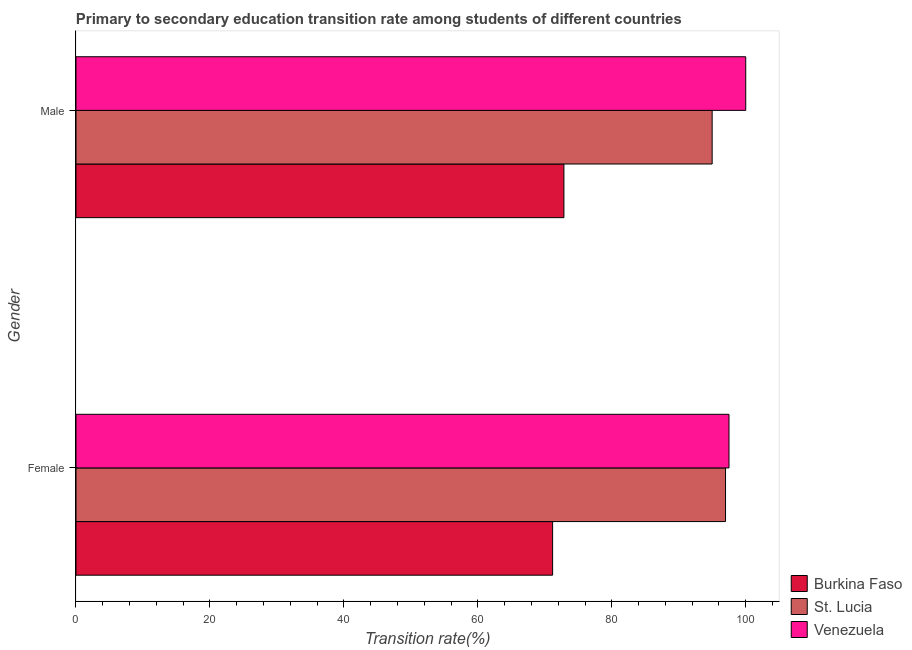What is the label of the 1st group of bars from the top?
Your answer should be compact. Male. What is the transition rate among female students in St. Lucia?
Your response must be concise. 96.98. Across all countries, what is the maximum transition rate among female students?
Offer a very short reply. 97.5. Across all countries, what is the minimum transition rate among male students?
Your answer should be compact. 72.85. In which country was the transition rate among female students maximum?
Keep it short and to the point. Venezuela. In which country was the transition rate among male students minimum?
Ensure brevity in your answer.  Burkina Faso. What is the total transition rate among female students in the graph?
Keep it short and to the point. 265.65. What is the difference between the transition rate among female students in Venezuela and that in St. Lucia?
Keep it short and to the point. 0.52. What is the difference between the transition rate among female students in St. Lucia and the transition rate among male students in Venezuela?
Your response must be concise. -3.02. What is the average transition rate among female students per country?
Keep it short and to the point. 88.55. What is the difference between the transition rate among male students and transition rate among female students in Venezuela?
Give a very brief answer. 2.5. What is the ratio of the transition rate among male students in Burkina Faso to that in Venezuela?
Your response must be concise. 0.73. Is the transition rate among male students in Venezuela less than that in Burkina Faso?
Your answer should be very brief. No. What does the 2nd bar from the top in Male represents?
Keep it short and to the point. St. Lucia. What does the 1st bar from the bottom in Female represents?
Your answer should be very brief. Burkina Faso. Are all the bars in the graph horizontal?
Make the answer very short. Yes. What is the difference between two consecutive major ticks on the X-axis?
Make the answer very short. 20. Does the graph contain any zero values?
Provide a succinct answer. No. Does the graph contain grids?
Your answer should be compact. No. Where does the legend appear in the graph?
Keep it short and to the point. Bottom right. How are the legend labels stacked?
Offer a very short reply. Vertical. What is the title of the graph?
Offer a very short reply. Primary to secondary education transition rate among students of different countries. Does "Kiribati" appear as one of the legend labels in the graph?
Offer a very short reply. No. What is the label or title of the X-axis?
Your answer should be very brief. Transition rate(%). What is the Transition rate(%) of Burkina Faso in Female?
Your response must be concise. 71.16. What is the Transition rate(%) in St. Lucia in Female?
Offer a terse response. 96.98. What is the Transition rate(%) in Venezuela in Female?
Make the answer very short. 97.5. What is the Transition rate(%) of Burkina Faso in Male?
Make the answer very short. 72.85. What is the Transition rate(%) of St. Lucia in Male?
Your response must be concise. 94.99. What is the Transition rate(%) in Venezuela in Male?
Ensure brevity in your answer.  100. Across all Gender, what is the maximum Transition rate(%) of Burkina Faso?
Give a very brief answer. 72.85. Across all Gender, what is the maximum Transition rate(%) in St. Lucia?
Ensure brevity in your answer.  96.98. Across all Gender, what is the maximum Transition rate(%) in Venezuela?
Ensure brevity in your answer.  100. Across all Gender, what is the minimum Transition rate(%) of Burkina Faso?
Make the answer very short. 71.16. Across all Gender, what is the minimum Transition rate(%) of St. Lucia?
Keep it short and to the point. 94.99. Across all Gender, what is the minimum Transition rate(%) of Venezuela?
Keep it short and to the point. 97.5. What is the total Transition rate(%) of Burkina Faso in the graph?
Provide a short and direct response. 144.02. What is the total Transition rate(%) in St. Lucia in the graph?
Offer a very short reply. 191.97. What is the total Transition rate(%) in Venezuela in the graph?
Your response must be concise. 197.5. What is the difference between the Transition rate(%) in Burkina Faso in Female and that in Male?
Offer a very short reply. -1.69. What is the difference between the Transition rate(%) of St. Lucia in Female and that in Male?
Give a very brief answer. 2. What is the difference between the Transition rate(%) in Venezuela in Female and that in Male?
Give a very brief answer. -2.5. What is the difference between the Transition rate(%) in Burkina Faso in Female and the Transition rate(%) in St. Lucia in Male?
Give a very brief answer. -23.82. What is the difference between the Transition rate(%) of Burkina Faso in Female and the Transition rate(%) of Venezuela in Male?
Your answer should be compact. -28.84. What is the difference between the Transition rate(%) in St. Lucia in Female and the Transition rate(%) in Venezuela in Male?
Keep it short and to the point. -3.02. What is the average Transition rate(%) of Burkina Faso per Gender?
Ensure brevity in your answer.  72.01. What is the average Transition rate(%) in St. Lucia per Gender?
Give a very brief answer. 95.98. What is the average Transition rate(%) in Venezuela per Gender?
Keep it short and to the point. 98.75. What is the difference between the Transition rate(%) of Burkina Faso and Transition rate(%) of St. Lucia in Female?
Offer a very short reply. -25.82. What is the difference between the Transition rate(%) in Burkina Faso and Transition rate(%) in Venezuela in Female?
Keep it short and to the point. -26.34. What is the difference between the Transition rate(%) in St. Lucia and Transition rate(%) in Venezuela in Female?
Keep it short and to the point. -0.52. What is the difference between the Transition rate(%) in Burkina Faso and Transition rate(%) in St. Lucia in Male?
Your response must be concise. -22.13. What is the difference between the Transition rate(%) of Burkina Faso and Transition rate(%) of Venezuela in Male?
Keep it short and to the point. -27.15. What is the difference between the Transition rate(%) in St. Lucia and Transition rate(%) in Venezuela in Male?
Offer a very short reply. -5.01. What is the ratio of the Transition rate(%) in Burkina Faso in Female to that in Male?
Offer a very short reply. 0.98. What is the ratio of the Transition rate(%) in Venezuela in Female to that in Male?
Ensure brevity in your answer.  0.97. What is the difference between the highest and the second highest Transition rate(%) of Burkina Faso?
Offer a very short reply. 1.69. What is the difference between the highest and the second highest Transition rate(%) in St. Lucia?
Your answer should be very brief. 2. What is the difference between the highest and the second highest Transition rate(%) in Venezuela?
Ensure brevity in your answer.  2.5. What is the difference between the highest and the lowest Transition rate(%) of Burkina Faso?
Offer a very short reply. 1.69. What is the difference between the highest and the lowest Transition rate(%) in St. Lucia?
Keep it short and to the point. 2. What is the difference between the highest and the lowest Transition rate(%) of Venezuela?
Your answer should be compact. 2.5. 